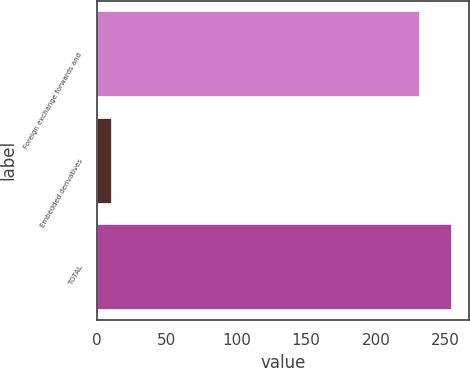Convert chart to OTSL. <chart><loc_0><loc_0><loc_500><loc_500><bar_chart><fcel>Foreign exchange forwards and<fcel>Embedded derivatives<fcel>TOTAL<nl><fcel>231<fcel>10<fcel>254.1<nl></chart> 